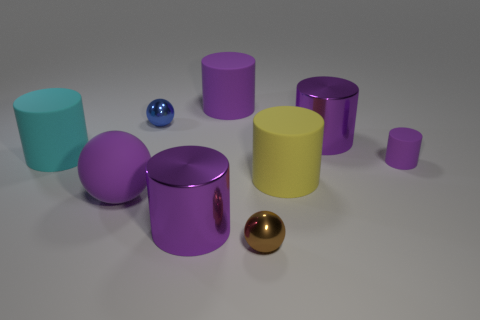Subtract all purple spheres. How many purple cylinders are left? 4 Subtract 4 cylinders. How many cylinders are left? 2 Subtract all yellow cylinders. How many cylinders are left? 5 Subtract all big metallic cylinders. How many cylinders are left? 4 Subtract all green cylinders. Subtract all purple balls. How many cylinders are left? 6 Add 1 tiny purple matte objects. How many objects exist? 10 Subtract all spheres. How many objects are left? 6 Add 8 large cyan rubber cylinders. How many large cyan rubber cylinders are left? 9 Add 4 shiny things. How many shiny things exist? 8 Subtract 0 blue cylinders. How many objects are left? 9 